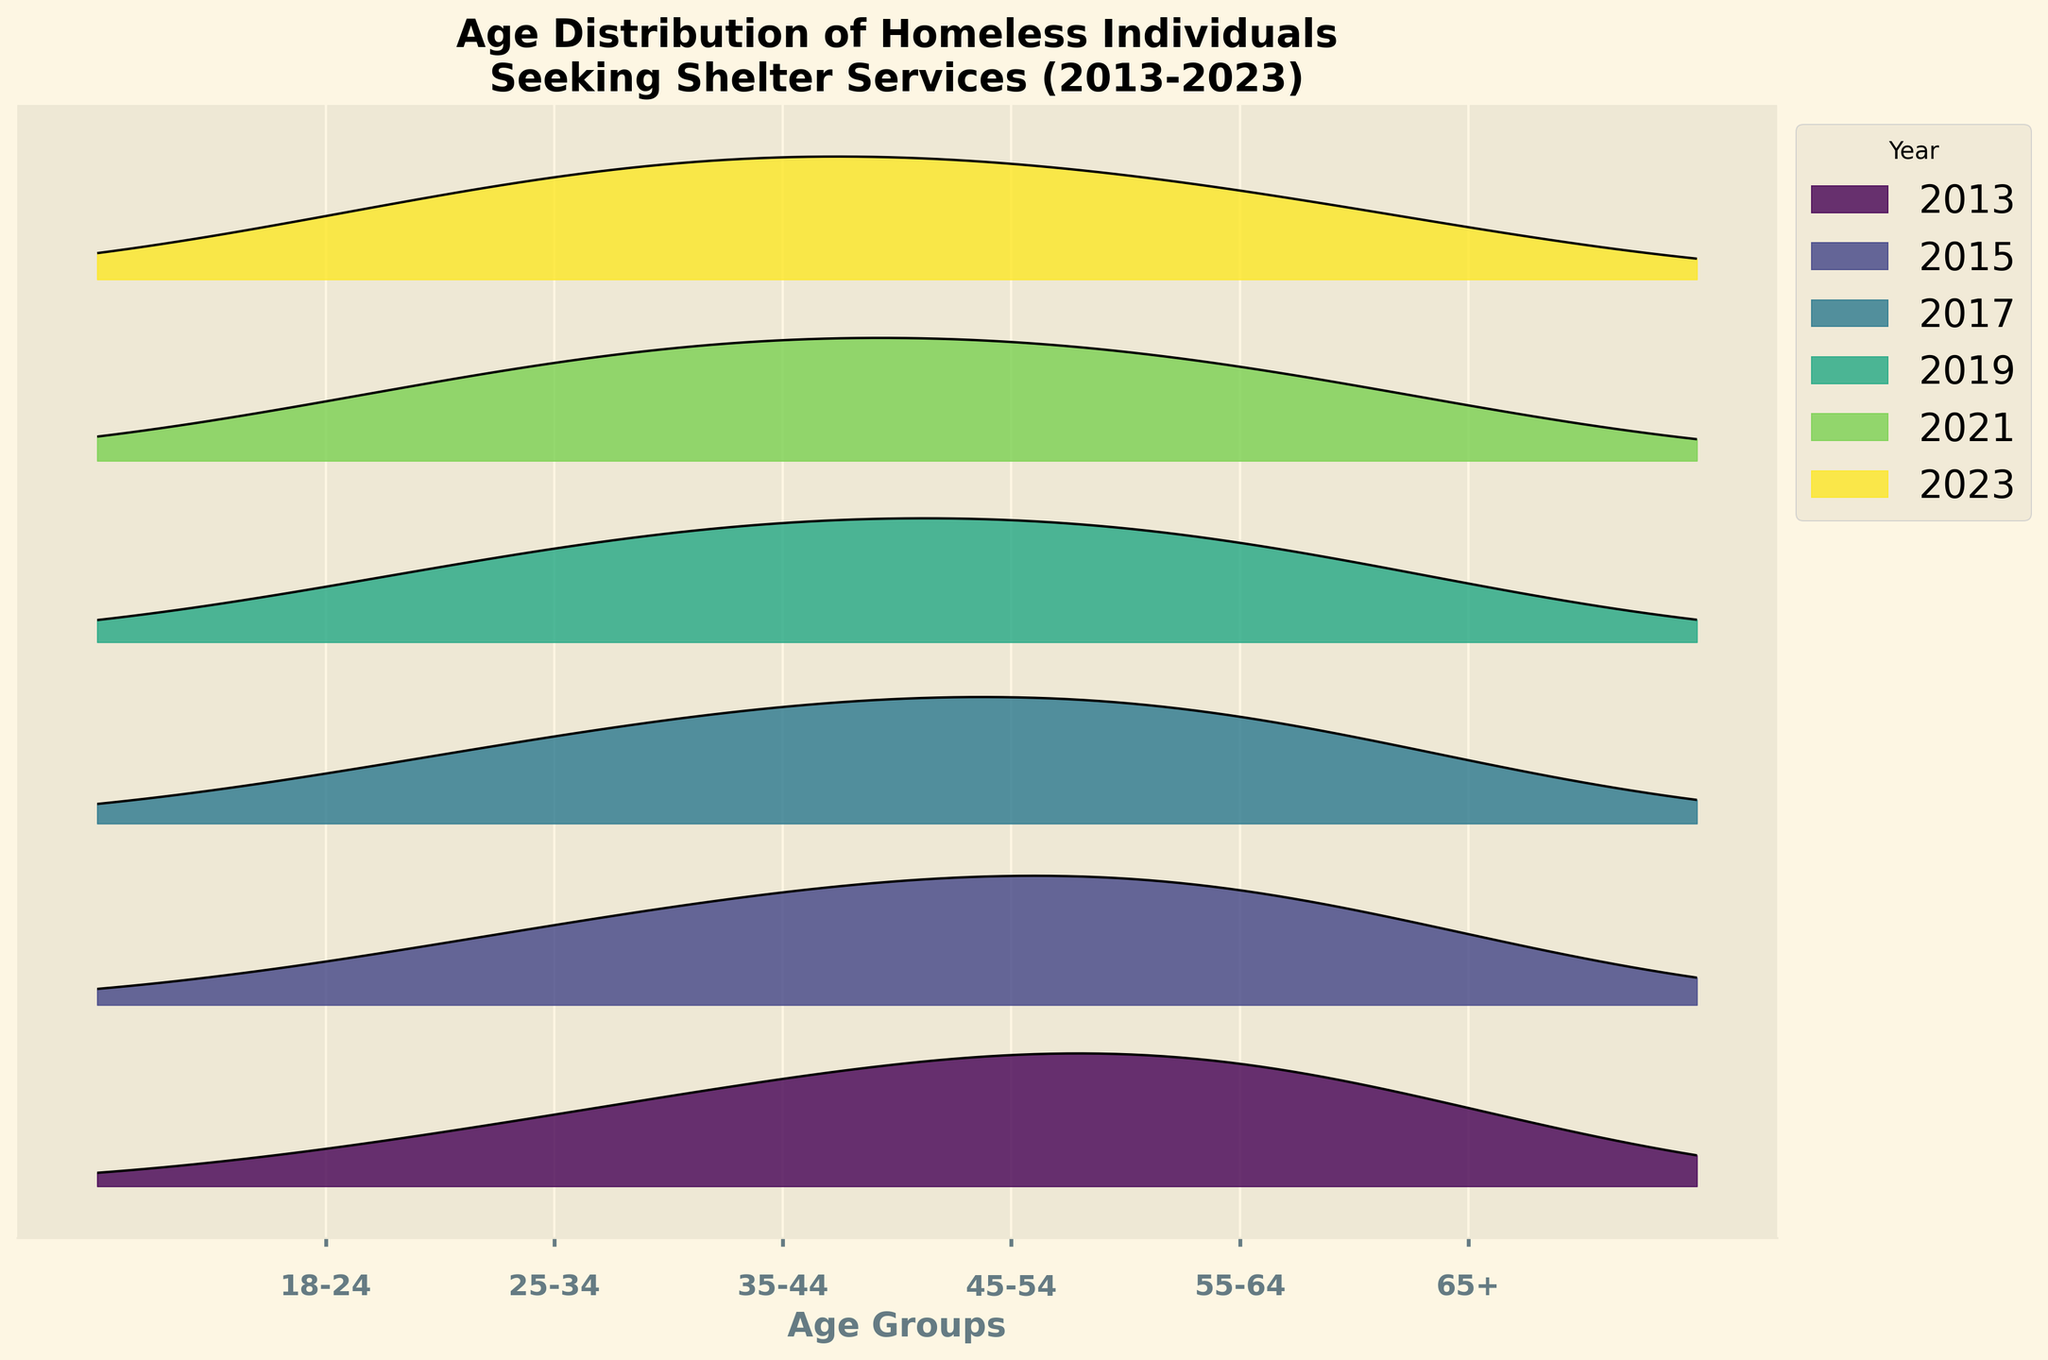What is the title of the figure? The title of the figure is typically displayed at the top of the plot. In this case, the title reads "Age Distribution of Homeless Individuals Seeking Shelter Services (2013-2023)."
Answer: Age Distribution of Homeless Individuals Seeking Shelter Services (2013-2023) What are the age groups shown on the x-axis? The x-axis displays the age groups being analyzed. They are listed as: '18-24', '25-34', '35-44', '45-54', '55-64', and '65+'.
Answer: '18-24', '25-34', '35-44', '45-54', '55-64', '65+' Which year has the highest density for the "55-64" age group? By observing the plot, we can see that the year with the highest density in the "55-64" age group has the tallest peak for that age group. For "55-64," the highest peak is in the year 2013.
Answer: 2013 How does the density for the "18-24" age group change from 2013 to 2023? One needs to compare the density values or heights of the ridgelines for the "18-24" age group across the years 2013 and 2023 to see the change. In 2013, the density is at a particular height, and in 2023, it has increased further. This indicates an increase in density over the decade.
Answer: Increases Which year has the lowest density overall for all age groups combined? By examining the heights of the ridgelines overall for all age groups across different years, the year with the consistently lowest ridgeline heights will be identified. 2013 and 2015 have similar overall lower densities compared to other years.
Answer: 2013 or 2015 What trend can be observed for the "65+" age group density over the years? To determine the trend, one needs to compare the heights of the ridgelines for the "65+" age group across the years. The density of the "65+" age group is highest in 2013 and gradually decreases. This indicates a downward trend over the years.
Answer: Decreases Compare the peak densities of the "35-44" age group in 2015 and 2021. Which year had a higher density? To answer this question, one must look at the heights of the peaks for the "35-44" age group in each of the years mentioned. The "35-44" age group has a higher peak in 2021 compared to 2015.
Answer: 2021 What is the relationship between age group and density in 2023? In 2023, the relationship between the age group and density can be seen by looking at the heights of the ridgelines. As the age group increases from "18-24" to "65+", the density initially increases until it peaks at "35-44" and then steadily decreases.
Answer: Peaks at "35-44", then decreases 